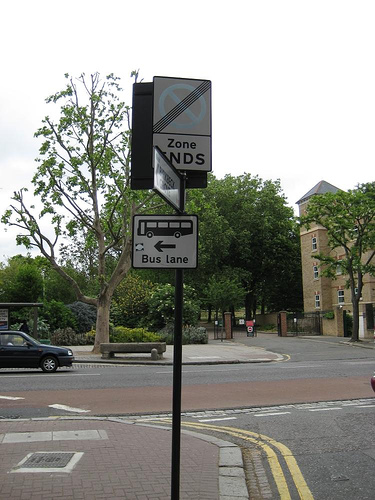Read all the text in this image. ZONE NDS Bus LANE 